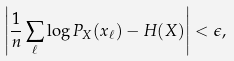<formula> <loc_0><loc_0><loc_500><loc_500>\left | \frac { 1 } { n } \sum _ { \ell } \log P _ { X } ( x _ { \ell } ) - H ( X ) \right | < \epsilon ,</formula> 